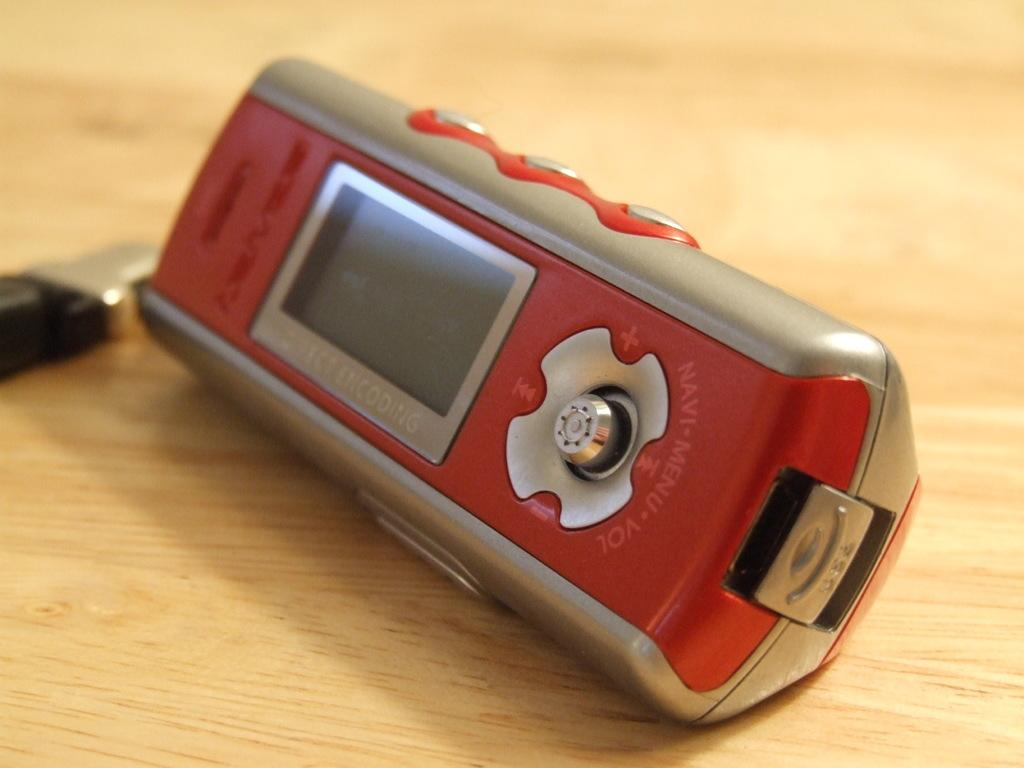What is the main object in the image? There is a device in the image. Where is the device located? The device is placed on a table. How many icicles are hanging from the device in the image? There are no icicles present in the image. What word is written on the device in the image? There is no text visible on the device in the image. 